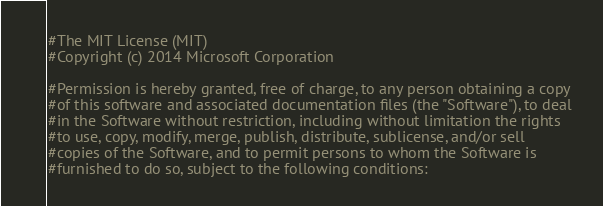<code> <loc_0><loc_0><loc_500><loc_500><_Python_>#The MIT License (MIT)
#Copyright (c) 2014 Microsoft Corporation

#Permission is hereby granted, free of charge, to any person obtaining a copy
#of this software and associated documentation files (the "Software"), to deal
#in the Software without restriction, including without limitation the rights
#to use, copy, modify, merge, publish, distribute, sublicense, and/or sell
#copies of the Software, and to permit persons to whom the Software is
#furnished to do so, subject to the following conditions:
</code> 